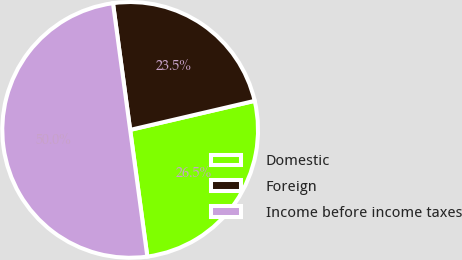<chart> <loc_0><loc_0><loc_500><loc_500><pie_chart><fcel>Domestic<fcel>Foreign<fcel>Income before income taxes<nl><fcel>26.5%<fcel>23.5%<fcel>50.0%<nl></chart> 